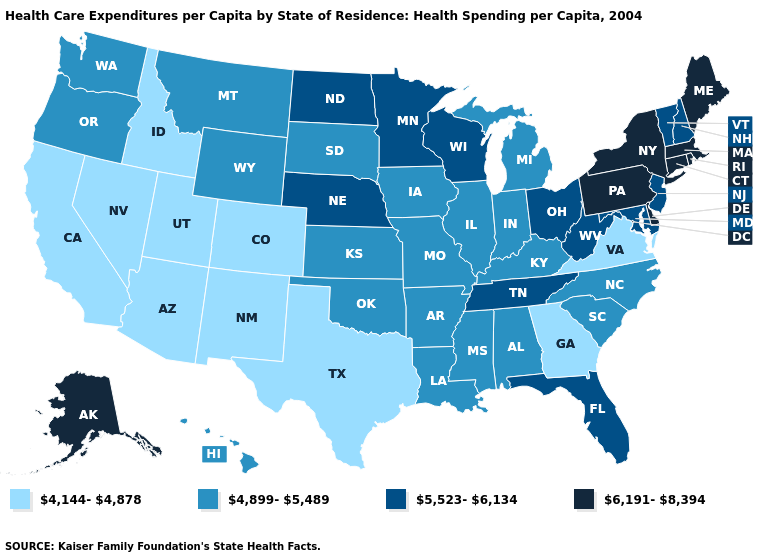What is the value of Utah?
Write a very short answer. 4,144-4,878. How many symbols are there in the legend?
Short answer required. 4. Among the states that border Kansas , which have the highest value?
Keep it brief. Nebraska. Does the map have missing data?
Give a very brief answer. No. What is the value of Tennessee?
Keep it brief. 5,523-6,134. Name the states that have a value in the range 4,144-4,878?
Give a very brief answer. Arizona, California, Colorado, Georgia, Idaho, Nevada, New Mexico, Texas, Utah, Virginia. Among the states that border New Jersey , which have the highest value?
Concise answer only. Delaware, New York, Pennsylvania. Name the states that have a value in the range 6,191-8,394?
Concise answer only. Alaska, Connecticut, Delaware, Maine, Massachusetts, New York, Pennsylvania, Rhode Island. Does the first symbol in the legend represent the smallest category?
Keep it brief. Yes. Does the first symbol in the legend represent the smallest category?
Write a very short answer. Yes. Name the states that have a value in the range 6,191-8,394?
Concise answer only. Alaska, Connecticut, Delaware, Maine, Massachusetts, New York, Pennsylvania, Rhode Island. Which states have the lowest value in the USA?
Keep it brief. Arizona, California, Colorado, Georgia, Idaho, Nevada, New Mexico, Texas, Utah, Virginia. Which states have the highest value in the USA?
Concise answer only. Alaska, Connecticut, Delaware, Maine, Massachusetts, New York, Pennsylvania, Rhode Island. Among the states that border Illinois , does Kentucky have the highest value?
Quick response, please. No. 